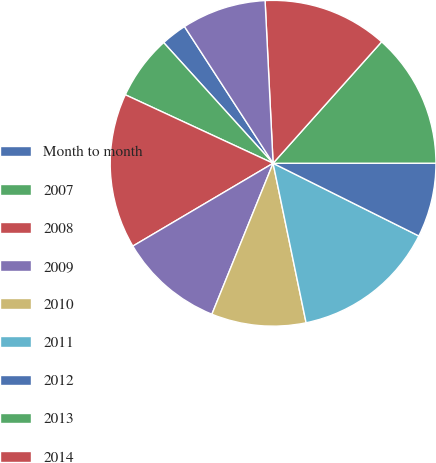<chart> <loc_0><loc_0><loc_500><loc_500><pie_chart><fcel>Month to month<fcel>2007<fcel>2008<fcel>2009<fcel>2010<fcel>2011<fcel>2012<fcel>2013<fcel>2014<fcel>2015<nl><fcel>2.57%<fcel>6.37%<fcel>15.4%<fcel>10.38%<fcel>9.38%<fcel>14.39%<fcel>7.37%<fcel>13.39%<fcel>12.39%<fcel>8.37%<nl></chart> 